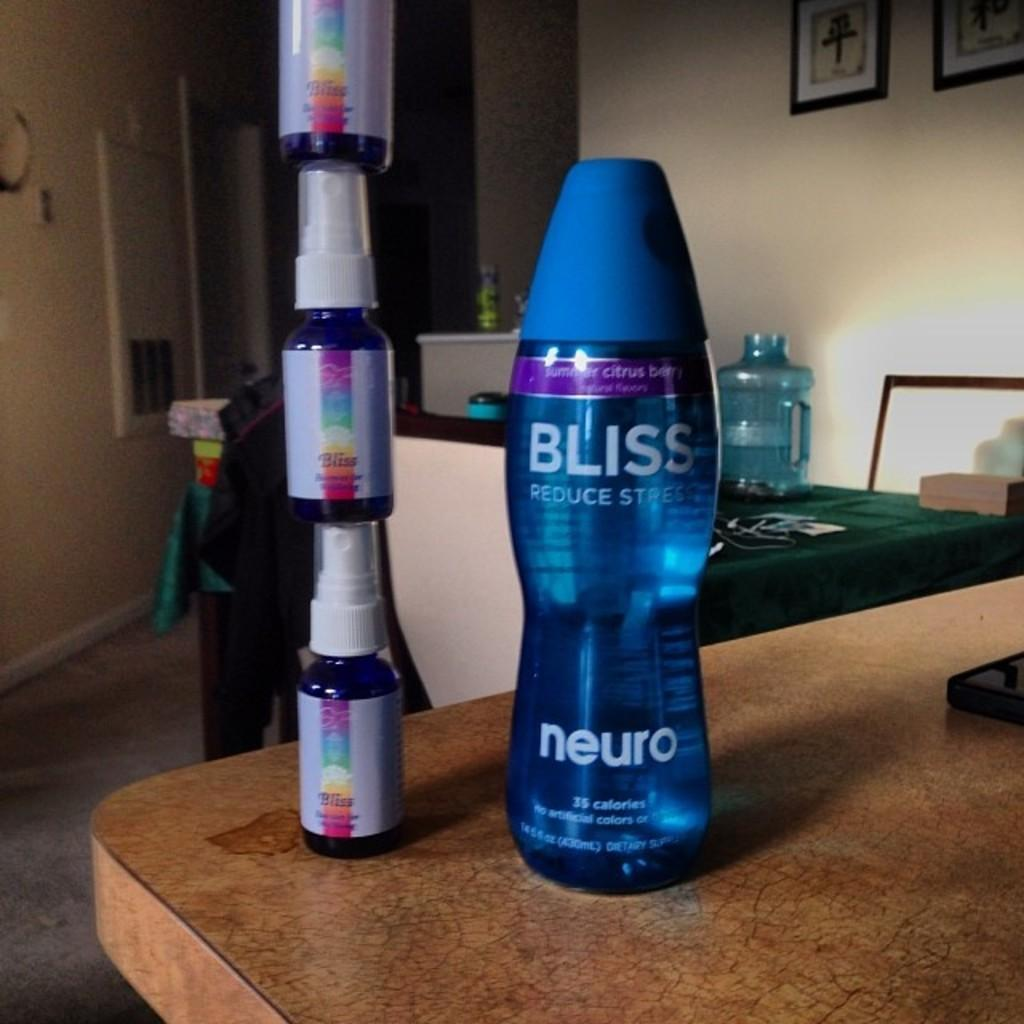Provide a one-sentence caption for the provided image. A blue Bliss brand drink is on the table next to rainbow colored Bliss drinks that are stacked on top of each other. 